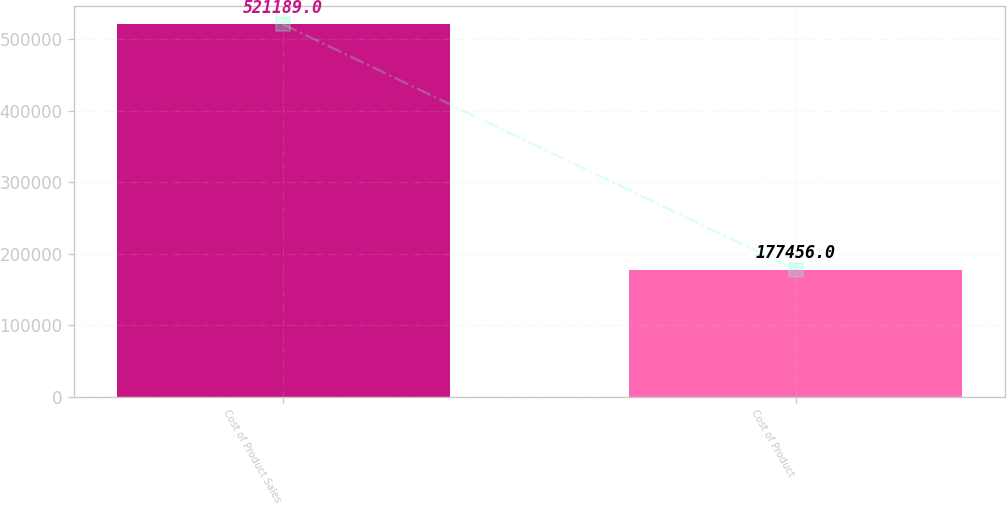<chart> <loc_0><loc_0><loc_500><loc_500><bar_chart><fcel>Cost of Product Sales<fcel>Cost of Product<nl><fcel>521189<fcel>177456<nl></chart> 